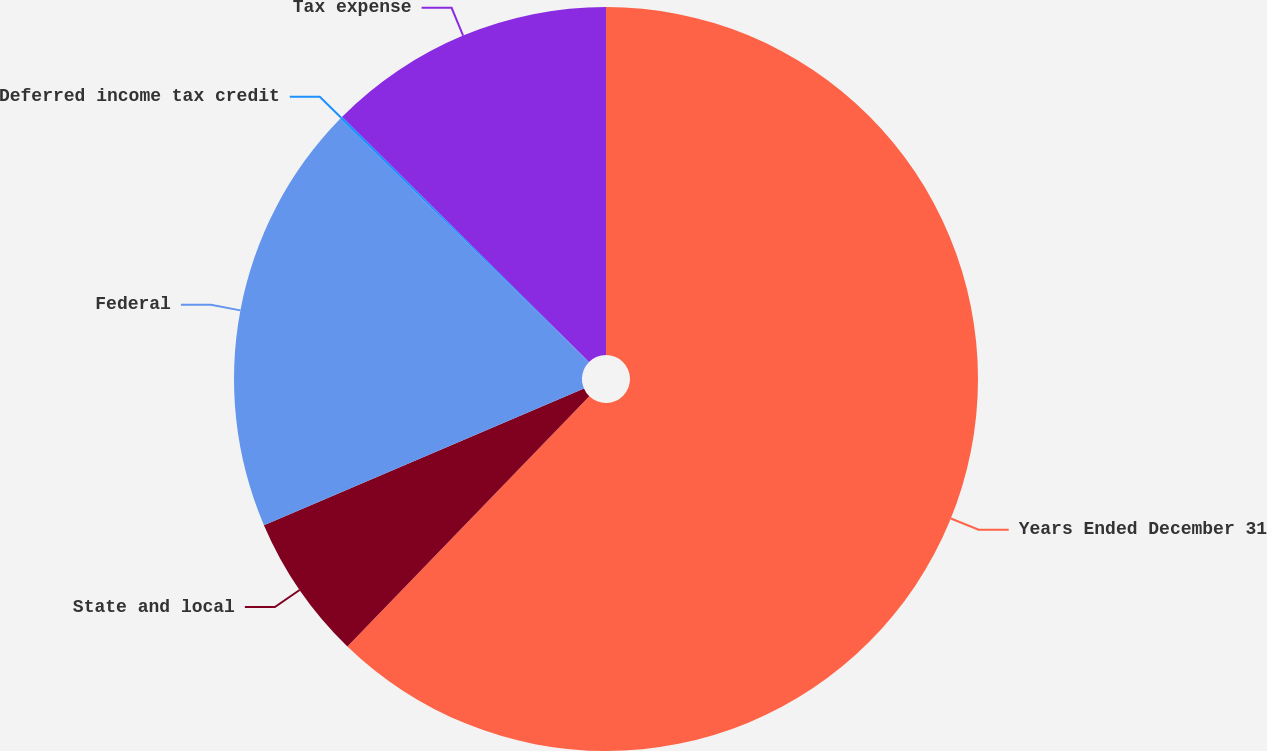<chart> <loc_0><loc_0><loc_500><loc_500><pie_chart><fcel>Years Ended December 31<fcel>State and local<fcel>Federal<fcel>Deferred income tax credit<fcel>Tax expense<nl><fcel>62.24%<fcel>6.34%<fcel>18.76%<fcel>0.12%<fcel>12.55%<nl></chart> 